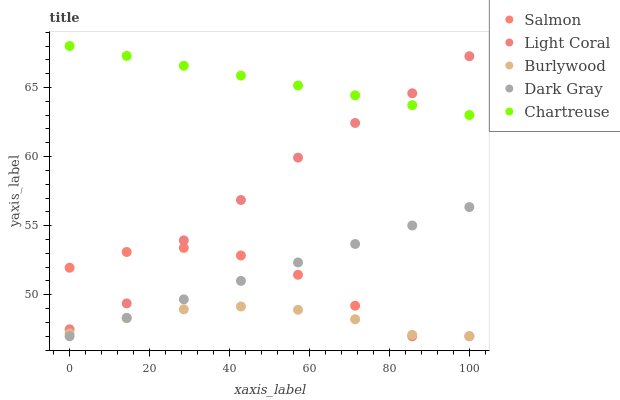Does Burlywood have the minimum area under the curve?
Answer yes or no. Yes. Does Chartreuse have the maximum area under the curve?
Answer yes or no. Yes. Does Chartreuse have the minimum area under the curve?
Answer yes or no. No. Does Burlywood have the maximum area under the curve?
Answer yes or no. No. Is Dark Gray the smoothest?
Answer yes or no. Yes. Is Light Coral the roughest?
Answer yes or no. Yes. Is Burlywood the smoothest?
Answer yes or no. No. Is Burlywood the roughest?
Answer yes or no. No. Does Burlywood have the lowest value?
Answer yes or no. Yes. Does Chartreuse have the lowest value?
Answer yes or no. No. Does Chartreuse have the highest value?
Answer yes or no. Yes. Does Burlywood have the highest value?
Answer yes or no. No. Is Burlywood less than Chartreuse?
Answer yes or no. Yes. Is Chartreuse greater than Salmon?
Answer yes or no. Yes. Does Salmon intersect Burlywood?
Answer yes or no. Yes. Is Salmon less than Burlywood?
Answer yes or no. No. Is Salmon greater than Burlywood?
Answer yes or no. No. Does Burlywood intersect Chartreuse?
Answer yes or no. No. 